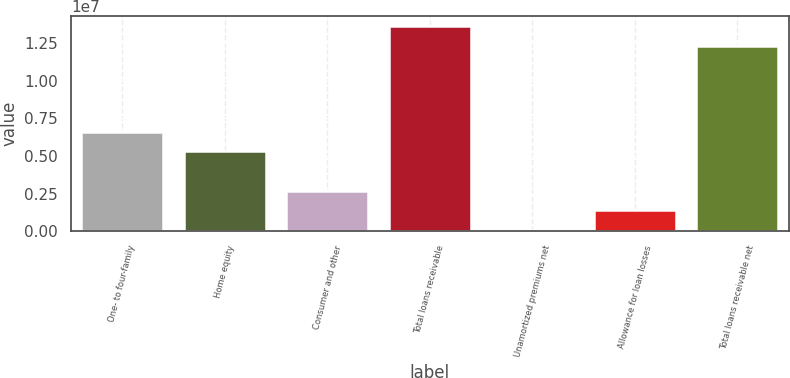Convert chart to OTSL. <chart><loc_0><loc_0><loc_500><loc_500><bar_chart><fcel>One- to four-family<fcel>Home equity<fcel>Consumer and other<fcel>Total loans receivable<fcel>Unamortized premiums net<fcel>Allowance for loan losses<fcel>Total loans receivable net<nl><fcel>6.62464e+06<fcel>5.32866e+06<fcel>2.68987e+06<fcel>1.36288e+07<fcel>97901<fcel>1.39388e+06<fcel>1.23328e+07<nl></chart> 